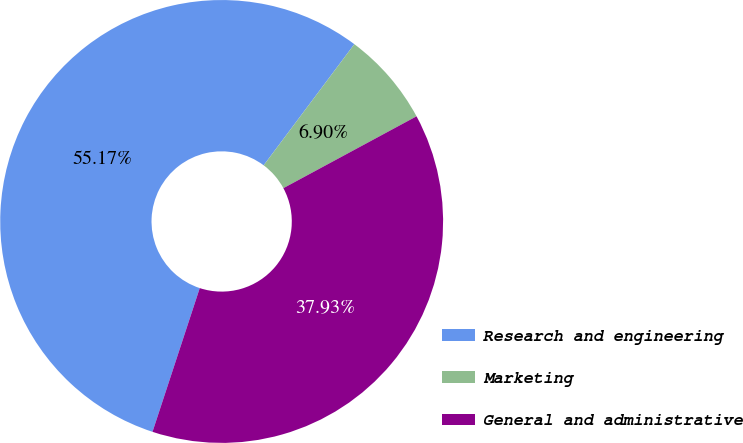<chart> <loc_0><loc_0><loc_500><loc_500><pie_chart><fcel>Research and engineering<fcel>Marketing<fcel>General and administrative<nl><fcel>55.17%<fcel>6.9%<fcel>37.93%<nl></chart> 